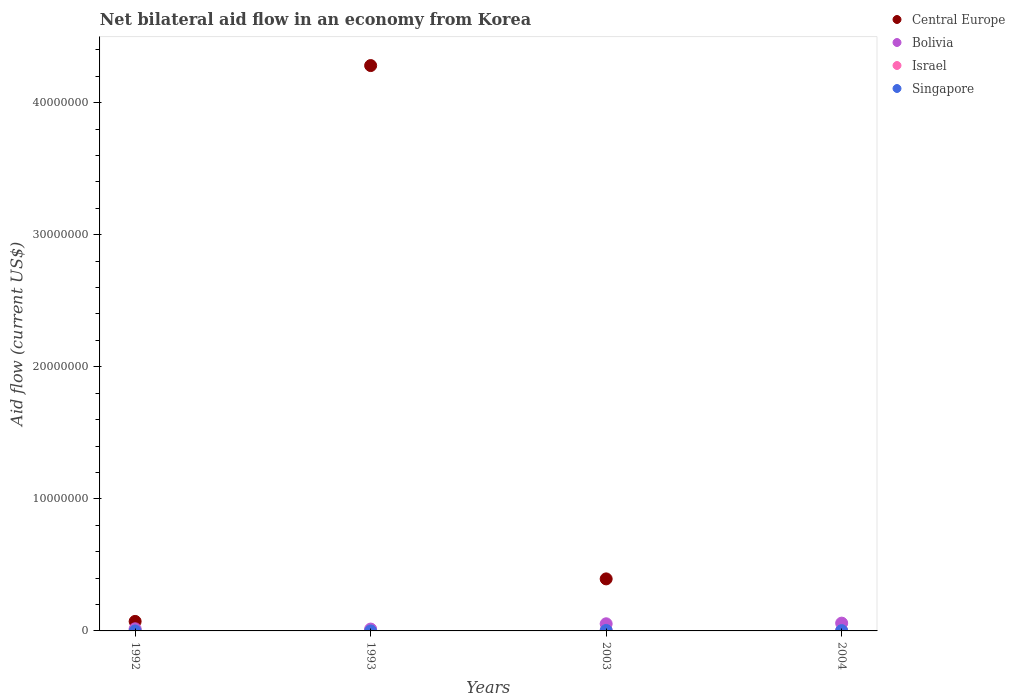Is the number of dotlines equal to the number of legend labels?
Your answer should be very brief. No. What is the net bilateral aid flow in Bolivia in 1992?
Provide a short and direct response. 1.60e+05. Across all years, what is the maximum net bilateral aid flow in Singapore?
Offer a terse response. 4.00e+04. What is the average net bilateral aid flow in Israel per year?
Your answer should be compact. 2.50e+04. In the year 1993, what is the difference between the net bilateral aid flow in Singapore and net bilateral aid flow in Bolivia?
Your answer should be very brief. -1.30e+05. What is the ratio of the net bilateral aid flow in Bolivia in 1993 to that in 2004?
Provide a succinct answer. 0.24. Is the net bilateral aid flow in Singapore in 1992 less than that in 2004?
Keep it short and to the point. Yes. Is the difference between the net bilateral aid flow in Singapore in 1992 and 2004 greater than the difference between the net bilateral aid flow in Bolivia in 1992 and 2004?
Keep it short and to the point. Yes. What is the difference between the highest and the lowest net bilateral aid flow in Central Europe?
Offer a very short reply. 4.28e+07. Is the sum of the net bilateral aid flow in Bolivia in 1992 and 2003 greater than the maximum net bilateral aid flow in Central Europe across all years?
Your response must be concise. No. Is it the case that in every year, the sum of the net bilateral aid flow in Central Europe and net bilateral aid flow in Israel  is greater than the sum of net bilateral aid flow in Singapore and net bilateral aid flow in Bolivia?
Provide a succinct answer. No. Does the net bilateral aid flow in Israel monotonically increase over the years?
Your answer should be compact. No. Is the net bilateral aid flow in Israel strictly greater than the net bilateral aid flow in Singapore over the years?
Your answer should be compact. No. Is the net bilateral aid flow in Israel strictly less than the net bilateral aid flow in Central Europe over the years?
Your response must be concise. No. What is the difference between two consecutive major ticks on the Y-axis?
Your response must be concise. 1.00e+07. Are the values on the major ticks of Y-axis written in scientific E-notation?
Make the answer very short. No. Does the graph contain any zero values?
Ensure brevity in your answer.  Yes. Does the graph contain grids?
Make the answer very short. No. Where does the legend appear in the graph?
Your answer should be compact. Top right. How many legend labels are there?
Offer a terse response. 4. How are the legend labels stacked?
Provide a succinct answer. Vertical. What is the title of the graph?
Give a very brief answer. Net bilateral aid flow in an economy from Korea. What is the label or title of the X-axis?
Provide a succinct answer. Years. What is the label or title of the Y-axis?
Offer a terse response. Aid flow (current US$). What is the Aid flow (current US$) of Central Europe in 1992?
Provide a short and direct response. 7.20e+05. What is the Aid flow (current US$) in Bolivia in 1992?
Your answer should be very brief. 1.60e+05. What is the Aid flow (current US$) in Israel in 1992?
Make the answer very short. 2.00e+04. What is the Aid flow (current US$) of Central Europe in 1993?
Make the answer very short. 4.28e+07. What is the Aid flow (current US$) of Bolivia in 1993?
Your answer should be very brief. 1.40e+05. What is the Aid flow (current US$) in Israel in 1993?
Your response must be concise. 2.00e+04. What is the Aid flow (current US$) in Central Europe in 2003?
Give a very brief answer. 3.94e+06. What is the Aid flow (current US$) in Bolivia in 2003?
Keep it short and to the point. 5.40e+05. What is the Aid flow (current US$) in Israel in 2003?
Your answer should be very brief. 3.00e+04. What is the Aid flow (current US$) of Bolivia in 2004?
Provide a succinct answer. 5.90e+05. What is the Aid flow (current US$) in Israel in 2004?
Provide a succinct answer. 3.00e+04. Across all years, what is the maximum Aid flow (current US$) in Central Europe?
Make the answer very short. 4.28e+07. Across all years, what is the maximum Aid flow (current US$) of Bolivia?
Provide a succinct answer. 5.90e+05. Across all years, what is the maximum Aid flow (current US$) in Singapore?
Ensure brevity in your answer.  4.00e+04. Across all years, what is the minimum Aid flow (current US$) in Singapore?
Ensure brevity in your answer.  10000. What is the total Aid flow (current US$) of Central Europe in the graph?
Your answer should be compact. 4.75e+07. What is the total Aid flow (current US$) in Bolivia in the graph?
Keep it short and to the point. 1.43e+06. What is the total Aid flow (current US$) in Israel in the graph?
Offer a very short reply. 1.00e+05. What is the total Aid flow (current US$) of Singapore in the graph?
Ensure brevity in your answer.  9.00e+04. What is the difference between the Aid flow (current US$) of Central Europe in 1992 and that in 1993?
Offer a terse response. -4.21e+07. What is the difference between the Aid flow (current US$) of Singapore in 1992 and that in 1993?
Make the answer very short. 0. What is the difference between the Aid flow (current US$) in Central Europe in 1992 and that in 2003?
Your response must be concise. -3.22e+06. What is the difference between the Aid flow (current US$) in Bolivia in 1992 and that in 2003?
Provide a short and direct response. -3.80e+05. What is the difference between the Aid flow (current US$) in Bolivia in 1992 and that in 2004?
Provide a short and direct response. -4.30e+05. What is the difference between the Aid flow (current US$) in Israel in 1992 and that in 2004?
Provide a short and direct response. -10000. What is the difference between the Aid flow (current US$) in Singapore in 1992 and that in 2004?
Provide a succinct answer. -2.00e+04. What is the difference between the Aid flow (current US$) of Central Europe in 1993 and that in 2003?
Offer a very short reply. 3.89e+07. What is the difference between the Aid flow (current US$) of Bolivia in 1993 and that in 2003?
Your answer should be compact. -4.00e+05. What is the difference between the Aid flow (current US$) in Bolivia in 1993 and that in 2004?
Provide a short and direct response. -4.50e+05. What is the difference between the Aid flow (current US$) of Israel in 2003 and that in 2004?
Provide a short and direct response. 0. What is the difference between the Aid flow (current US$) in Singapore in 2003 and that in 2004?
Provide a short and direct response. 10000. What is the difference between the Aid flow (current US$) of Central Europe in 1992 and the Aid flow (current US$) of Bolivia in 1993?
Provide a succinct answer. 5.80e+05. What is the difference between the Aid flow (current US$) of Central Europe in 1992 and the Aid flow (current US$) of Israel in 1993?
Provide a short and direct response. 7.00e+05. What is the difference between the Aid flow (current US$) of Central Europe in 1992 and the Aid flow (current US$) of Singapore in 1993?
Your answer should be compact. 7.10e+05. What is the difference between the Aid flow (current US$) of Bolivia in 1992 and the Aid flow (current US$) of Israel in 1993?
Keep it short and to the point. 1.40e+05. What is the difference between the Aid flow (current US$) of Bolivia in 1992 and the Aid flow (current US$) of Singapore in 1993?
Offer a very short reply. 1.50e+05. What is the difference between the Aid flow (current US$) of Central Europe in 1992 and the Aid flow (current US$) of Israel in 2003?
Provide a short and direct response. 6.90e+05. What is the difference between the Aid flow (current US$) in Central Europe in 1992 and the Aid flow (current US$) in Singapore in 2003?
Your response must be concise. 6.80e+05. What is the difference between the Aid flow (current US$) in Bolivia in 1992 and the Aid flow (current US$) in Israel in 2003?
Your answer should be compact. 1.30e+05. What is the difference between the Aid flow (current US$) of Bolivia in 1992 and the Aid flow (current US$) of Singapore in 2003?
Provide a succinct answer. 1.20e+05. What is the difference between the Aid flow (current US$) of Israel in 1992 and the Aid flow (current US$) of Singapore in 2003?
Offer a terse response. -2.00e+04. What is the difference between the Aid flow (current US$) in Central Europe in 1992 and the Aid flow (current US$) in Israel in 2004?
Provide a short and direct response. 6.90e+05. What is the difference between the Aid flow (current US$) of Central Europe in 1992 and the Aid flow (current US$) of Singapore in 2004?
Offer a very short reply. 6.90e+05. What is the difference between the Aid flow (current US$) in Bolivia in 1992 and the Aid flow (current US$) in Singapore in 2004?
Keep it short and to the point. 1.30e+05. What is the difference between the Aid flow (current US$) in Israel in 1992 and the Aid flow (current US$) in Singapore in 2004?
Give a very brief answer. -10000. What is the difference between the Aid flow (current US$) in Central Europe in 1993 and the Aid flow (current US$) in Bolivia in 2003?
Give a very brief answer. 4.23e+07. What is the difference between the Aid flow (current US$) in Central Europe in 1993 and the Aid flow (current US$) in Israel in 2003?
Offer a terse response. 4.28e+07. What is the difference between the Aid flow (current US$) in Central Europe in 1993 and the Aid flow (current US$) in Singapore in 2003?
Provide a succinct answer. 4.28e+07. What is the difference between the Aid flow (current US$) of Central Europe in 1993 and the Aid flow (current US$) of Bolivia in 2004?
Provide a short and direct response. 4.22e+07. What is the difference between the Aid flow (current US$) of Central Europe in 1993 and the Aid flow (current US$) of Israel in 2004?
Your answer should be very brief. 4.28e+07. What is the difference between the Aid flow (current US$) of Central Europe in 1993 and the Aid flow (current US$) of Singapore in 2004?
Offer a very short reply. 4.28e+07. What is the difference between the Aid flow (current US$) of Bolivia in 1993 and the Aid flow (current US$) of Israel in 2004?
Offer a terse response. 1.10e+05. What is the difference between the Aid flow (current US$) in Israel in 1993 and the Aid flow (current US$) in Singapore in 2004?
Your answer should be compact. -10000. What is the difference between the Aid flow (current US$) of Central Europe in 2003 and the Aid flow (current US$) of Bolivia in 2004?
Provide a short and direct response. 3.35e+06. What is the difference between the Aid flow (current US$) of Central Europe in 2003 and the Aid flow (current US$) of Israel in 2004?
Give a very brief answer. 3.91e+06. What is the difference between the Aid flow (current US$) of Central Europe in 2003 and the Aid flow (current US$) of Singapore in 2004?
Your answer should be compact. 3.91e+06. What is the difference between the Aid flow (current US$) of Bolivia in 2003 and the Aid flow (current US$) of Israel in 2004?
Provide a succinct answer. 5.10e+05. What is the difference between the Aid flow (current US$) in Bolivia in 2003 and the Aid flow (current US$) in Singapore in 2004?
Make the answer very short. 5.10e+05. What is the difference between the Aid flow (current US$) of Israel in 2003 and the Aid flow (current US$) of Singapore in 2004?
Your response must be concise. 0. What is the average Aid flow (current US$) of Central Europe per year?
Provide a short and direct response. 1.19e+07. What is the average Aid flow (current US$) of Bolivia per year?
Provide a short and direct response. 3.58e+05. What is the average Aid flow (current US$) of Israel per year?
Your answer should be compact. 2.50e+04. What is the average Aid flow (current US$) in Singapore per year?
Make the answer very short. 2.25e+04. In the year 1992, what is the difference between the Aid flow (current US$) of Central Europe and Aid flow (current US$) of Bolivia?
Your answer should be compact. 5.60e+05. In the year 1992, what is the difference between the Aid flow (current US$) of Central Europe and Aid flow (current US$) of Singapore?
Provide a short and direct response. 7.10e+05. In the year 1992, what is the difference between the Aid flow (current US$) in Bolivia and Aid flow (current US$) in Israel?
Your answer should be very brief. 1.40e+05. In the year 1992, what is the difference between the Aid flow (current US$) in Israel and Aid flow (current US$) in Singapore?
Your answer should be very brief. 10000. In the year 1993, what is the difference between the Aid flow (current US$) of Central Europe and Aid flow (current US$) of Bolivia?
Offer a terse response. 4.27e+07. In the year 1993, what is the difference between the Aid flow (current US$) of Central Europe and Aid flow (current US$) of Israel?
Your response must be concise. 4.28e+07. In the year 1993, what is the difference between the Aid flow (current US$) of Central Europe and Aid flow (current US$) of Singapore?
Your response must be concise. 4.28e+07. In the year 1993, what is the difference between the Aid flow (current US$) of Bolivia and Aid flow (current US$) of Israel?
Your response must be concise. 1.20e+05. In the year 1993, what is the difference between the Aid flow (current US$) in Israel and Aid flow (current US$) in Singapore?
Your response must be concise. 10000. In the year 2003, what is the difference between the Aid flow (current US$) in Central Europe and Aid flow (current US$) in Bolivia?
Make the answer very short. 3.40e+06. In the year 2003, what is the difference between the Aid flow (current US$) in Central Europe and Aid flow (current US$) in Israel?
Make the answer very short. 3.91e+06. In the year 2003, what is the difference between the Aid flow (current US$) in Central Europe and Aid flow (current US$) in Singapore?
Offer a very short reply. 3.90e+06. In the year 2003, what is the difference between the Aid flow (current US$) of Bolivia and Aid flow (current US$) of Israel?
Provide a succinct answer. 5.10e+05. In the year 2003, what is the difference between the Aid flow (current US$) in Bolivia and Aid flow (current US$) in Singapore?
Offer a terse response. 5.00e+05. In the year 2003, what is the difference between the Aid flow (current US$) of Israel and Aid flow (current US$) of Singapore?
Keep it short and to the point. -10000. In the year 2004, what is the difference between the Aid flow (current US$) of Bolivia and Aid flow (current US$) of Israel?
Provide a succinct answer. 5.60e+05. In the year 2004, what is the difference between the Aid flow (current US$) of Bolivia and Aid flow (current US$) of Singapore?
Give a very brief answer. 5.60e+05. In the year 2004, what is the difference between the Aid flow (current US$) in Israel and Aid flow (current US$) in Singapore?
Offer a very short reply. 0. What is the ratio of the Aid flow (current US$) of Central Europe in 1992 to that in 1993?
Your answer should be very brief. 0.02. What is the ratio of the Aid flow (current US$) of Israel in 1992 to that in 1993?
Your response must be concise. 1. What is the ratio of the Aid flow (current US$) in Central Europe in 1992 to that in 2003?
Offer a terse response. 0.18. What is the ratio of the Aid flow (current US$) in Bolivia in 1992 to that in 2003?
Ensure brevity in your answer.  0.3. What is the ratio of the Aid flow (current US$) in Israel in 1992 to that in 2003?
Provide a short and direct response. 0.67. What is the ratio of the Aid flow (current US$) of Singapore in 1992 to that in 2003?
Make the answer very short. 0.25. What is the ratio of the Aid flow (current US$) of Bolivia in 1992 to that in 2004?
Make the answer very short. 0.27. What is the ratio of the Aid flow (current US$) of Israel in 1992 to that in 2004?
Keep it short and to the point. 0.67. What is the ratio of the Aid flow (current US$) of Central Europe in 1993 to that in 2003?
Offer a very short reply. 10.87. What is the ratio of the Aid flow (current US$) in Bolivia in 1993 to that in 2003?
Give a very brief answer. 0.26. What is the ratio of the Aid flow (current US$) in Singapore in 1993 to that in 2003?
Provide a succinct answer. 0.25. What is the ratio of the Aid flow (current US$) in Bolivia in 1993 to that in 2004?
Your answer should be very brief. 0.24. What is the ratio of the Aid flow (current US$) of Singapore in 1993 to that in 2004?
Give a very brief answer. 0.33. What is the ratio of the Aid flow (current US$) in Bolivia in 2003 to that in 2004?
Offer a very short reply. 0.92. What is the ratio of the Aid flow (current US$) of Israel in 2003 to that in 2004?
Keep it short and to the point. 1. What is the difference between the highest and the second highest Aid flow (current US$) in Central Europe?
Make the answer very short. 3.89e+07. What is the difference between the highest and the second highest Aid flow (current US$) in Bolivia?
Offer a terse response. 5.00e+04. What is the difference between the highest and the second highest Aid flow (current US$) in Singapore?
Your answer should be compact. 10000. What is the difference between the highest and the lowest Aid flow (current US$) of Central Europe?
Provide a short and direct response. 4.28e+07. What is the difference between the highest and the lowest Aid flow (current US$) in Israel?
Give a very brief answer. 10000. 